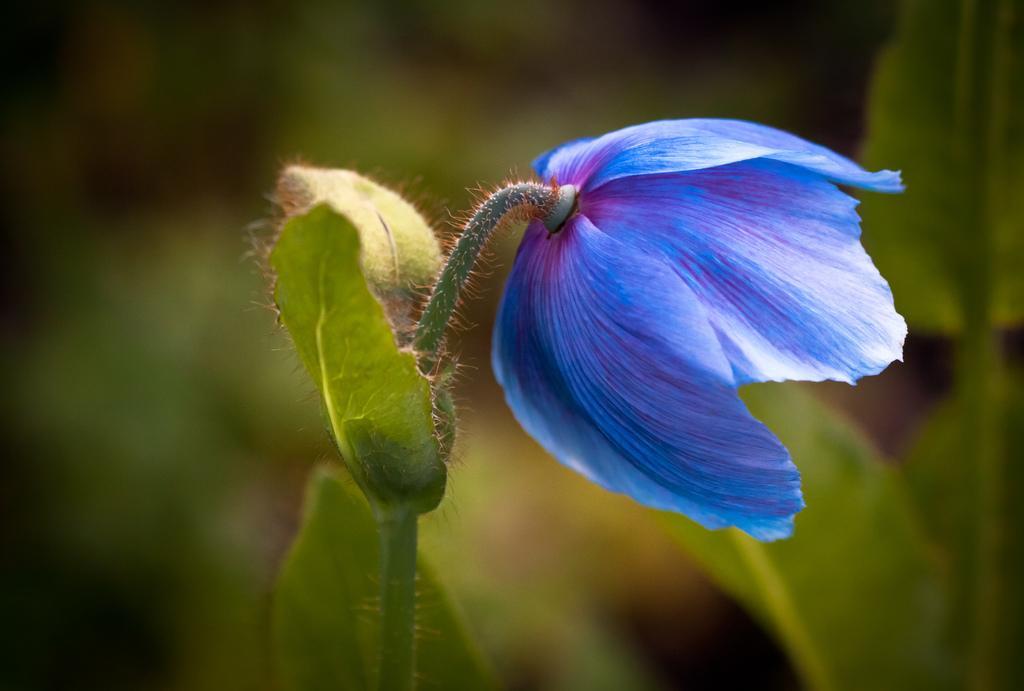Could you give a brief overview of what you see in this image? In this image we can see one plant with blue color flower, some plants and there is the green blurred background. 